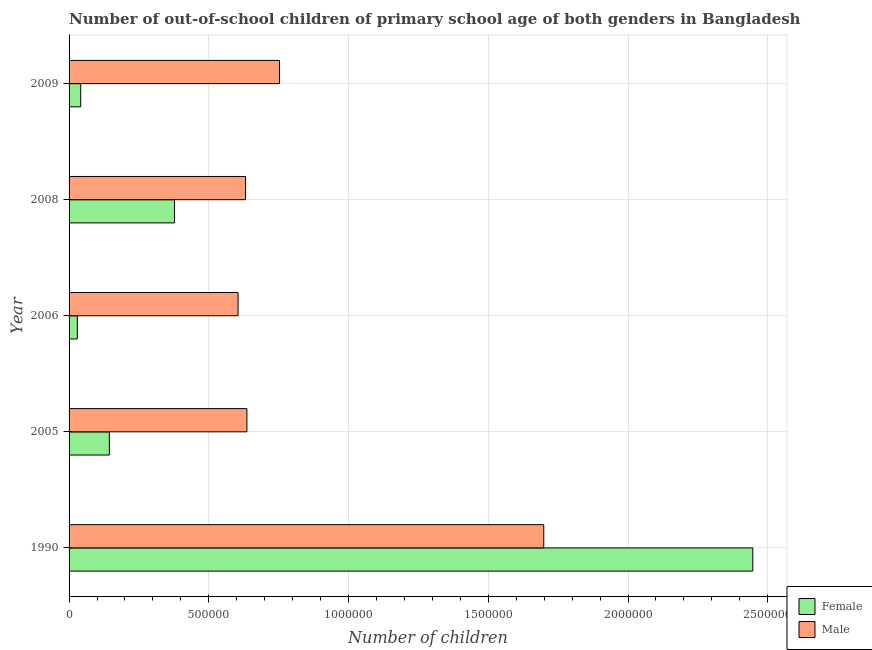How many different coloured bars are there?
Offer a very short reply. 2. Are the number of bars per tick equal to the number of legend labels?
Keep it short and to the point. Yes. How many bars are there on the 1st tick from the top?
Give a very brief answer. 2. In how many cases, is the number of bars for a given year not equal to the number of legend labels?
Provide a succinct answer. 0. What is the number of female out-of-school students in 2009?
Give a very brief answer. 4.16e+04. Across all years, what is the maximum number of female out-of-school students?
Offer a very short reply. 2.45e+06. Across all years, what is the minimum number of female out-of-school students?
Provide a succinct answer. 2.95e+04. In which year was the number of female out-of-school students maximum?
Offer a terse response. 1990. In which year was the number of male out-of-school students minimum?
Your answer should be very brief. 2006. What is the total number of female out-of-school students in the graph?
Offer a very short reply. 3.04e+06. What is the difference between the number of female out-of-school students in 2006 and that in 2008?
Make the answer very short. -3.48e+05. What is the difference between the number of male out-of-school students in 2005 and the number of female out-of-school students in 2008?
Your answer should be very brief. 2.59e+05. What is the average number of male out-of-school students per year?
Your answer should be very brief. 8.65e+05. In the year 2009, what is the difference between the number of female out-of-school students and number of male out-of-school students?
Ensure brevity in your answer.  -7.11e+05. In how many years, is the number of male out-of-school students greater than 900000 ?
Ensure brevity in your answer.  1. What is the ratio of the number of female out-of-school students in 1990 to that in 2009?
Provide a short and direct response. 58.8. Is the difference between the number of male out-of-school students in 1990 and 2008 greater than the difference between the number of female out-of-school students in 1990 and 2008?
Ensure brevity in your answer.  No. What is the difference between the highest and the second highest number of female out-of-school students?
Offer a terse response. 2.07e+06. What is the difference between the highest and the lowest number of male out-of-school students?
Give a very brief answer. 1.09e+06. In how many years, is the number of female out-of-school students greater than the average number of female out-of-school students taken over all years?
Provide a short and direct response. 1. Is the sum of the number of male out-of-school students in 1990 and 2006 greater than the maximum number of female out-of-school students across all years?
Ensure brevity in your answer.  No. Are all the bars in the graph horizontal?
Your answer should be very brief. Yes. How many years are there in the graph?
Ensure brevity in your answer.  5. What is the difference between two consecutive major ticks on the X-axis?
Offer a very short reply. 5.00e+05. Where does the legend appear in the graph?
Your answer should be compact. Bottom right. How many legend labels are there?
Ensure brevity in your answer.  2. How are the legend labels stacked?
Provide a short and direct response. Vertical. What is the title of the graph?
Your answer should be very brief. Number of out-of-school children of primary school age of both genders in Bangladesh. Does "Public funds" appear as one of the legend labels in the graph?
Your answer should be very brief. No. What is the label or title of the X-axis?
Provide a short and direct response. Number of children. What is the Number of children in Female in 1990?
Provide a short and direct response. 2.45e+06. What is the Number of children in Male in 1990?
Offer a very short reply. 1.70e+06. What is the Number of children in Female in 2005?
Make the answer very short. 1.44e+05. What is the Number of children in Male in 2005?
Your response must be concise. 6.36e+05. What is the Number of children of Female in 2006?
Make the answer very short. 2.95e+04. What is the Number of children of Male in 2006?
Your response must be concise. 6.05e+05. What is the Number of children in Female in 2008?
Ensure brevity in your answer.  3.77e+05. What is the Number of children of Male in 2008?
Make the answer very short. 6.31e+05. What is the Number of children in Female in 2009?
Your answer should be very brief. 4.16e+04. What is the Number of children in Male in 2009?
Provide a short and direct response. 7.53e+05. Across all years, what is the maximum Number of children of Female?
Ensure brevity in your answer.  2.45e+06. Across all years, what is the maximum Number of children in Male?
Make the answer very short. 1.70e+06. Across all years, what is the minimum Number of children of Female?
Offer a terse response. 2.95e+04. Across all years, what is the minimum Number of children of Male?
Offer a very short reply. 6.05e+05. What is the total Number of children of Female in the graph?
Offer a very short reply. 3.04e+06. What is the total Number of children in Male in the graph?
Offer a terse response. 4.32e+06. What is the difference between the Number of children in Female in 1990 and that in 2005?
Offer a terse response. 2.30e+06. What is the difference between the Number of children in Male in 1990 and that in 2005?
Your response must be concise. 1.06e+06. What is the difference between the Number of children in Female in 1990 and that in 2006?
Your response must be concise. 2.42e+06. What is the difference between the Number of children in Male in 1990 and that in 2006?
Your answer should be very brief. 1.09e+06. What is the difference between the Number of children of Female in 1990 and that in 2008?
Your answer should be compact. 2.07e+06. What is the difference between the Number of children of Male in 1990 and that in 2008?
Offer a very short reply. 1.07e+06. What is the difference between the Number of children of Female in 1990 and that in 2009?
Give a very brief answer. 2.40e+06. What is the difference between the Number of children of Male in 1990 and that in 2009?
Offer a very short reply. 9.46e+05. What is the difference between the Number of children of Female in 2005 and that in 2006?
Your answer should be compact. 1.15e+05. What is the difference between the Number of children of Male in 2005 and that in 2006?
Make the answer very short. 3.17e+04. What is the difference between the Number of children in Female in 2005 and that in 2008?
Keep it short and to the point. -2.33e+05. What is the difference between the Number of children of Male in 2005 and that in 2008?
Provide a succinct answer. 4960. What is the difference between the Number of children in Female in 2005 and that in 2009?
Your response must be concise. 1.02e+05. What is the difference between the Number of children in Male in 2005 and that in 2009?
Ensure brevity in your answer.  -1.16e+05. What is the difference between the Number of children in Female in 2006 and that in 2008?
Your answer should be compact. -3.48e+05. What is the difference between the Number of children of Male in 2006 and that in 2008?
Your answer should be compact. -2.67e+04. What is the difference between the Number of children of Female in 2006 and that in 2009?
Offer a very short reply. -1.21e+04. What is the difference between the Number of children in Male in 2006 and that in 2009?
Give a very brief answer. -1.48e+05. What is the difference between the Number of children in Female in 2008 and that in 2009?
Provide a succinct answer. 3.36e+05. What is the difference between the Number of children of Male in 2008 and that in 2009?
Give a very brief answer. -1.21e+05. What is the difference between the Number of children in Female in 1990 and the Number of children in Male in 2005?
Provide a succinct answer. 1.81e+06. What is the difference between the Number of children of Female in 1990 and the Number of children of Male in 2006?
Provide a short and direct response. 1.84e+06. What is the difference between the Number of children of Female in 1990 and the Number of children of Male in 2008?
Provide a succinct answer. 1.82e+06. What is the difference between the Number of children of Female in 1990 and the Number of children of Male in 2009?
Give a very brief answer. 1.69e+06. What is the difference between the Number of children in Female in 2005 and the Number of children in Male in 2006?
Ensure brevity in your answer.  -4.61e+05. What is the difference between the Number of children of Female in 2005 and the Number of children of Male in 2008?
Make the answer very short. -4.87e+05. What is the difference between the Number of children in Female in 2005 and the Number of children in Male in 2009?
Keep it short and to the point. -6.09e+05. What is the difference between the Number of children in Female in 2006 and the Number of children in Male in 2008?
Give a very brief answer. -6.02e+05. What is the difference between the Number of children of Female in 2006 and the Number of children of Male in 2009?
Keep it short and to the point. -7.23e+05. What is the difference between the Number of children in Female in 2008 and the Number of children in Male in 2009?
Keep it short and to the point. -3.76e+05. What is the average Number of children in Female per year?
Your response must be concise. 6.08e+05. What is the average Number of children in Male per year?
Your answer should be very brief. 8.65e+05. In the year 1990, what is the difference between the Number of children in Female and Number of children in Male?
Provide a succinct answer. 7.48e+05. In the year 2005, what is the difference between the Number of children in Female and Number of children in Male?
Make the answer very short. -4.92e+05. In the year 2006, what is the difference between the Number of children of Female and Number of children of Male?
Your answer should be compact. -5.75e+05. In the year 2008, what is the difference between the Number of children in Female and Number of children in Male?
Offer a very short reply. -2.54e+05. In the year 2009, what is the difference between the Number of children in Female and Number of children in Male?
Your response must be concise. -7.11e+05. What is the ratio of the Number of children of Female in 1990 to that in 2005?
Your response must be concise. 16.98. What is the ratio of the Number of children in Male in 1990 to that in 2005?
Ensure brevity in your answer.  2.67. What is the ratio of the Number of children in Female in 1990 to that in 2006?
Offer a very short reply. 82.8. What is the ratio of the Number of children in Male in 1990 to that in 2006?
Make the answer very short. 2.81. What is the ratio of the Number of children in Female in 1990 to that in 2008?
Ensure brevity in your answer.  6.49. What is the ratio of the Number of children in Male in 1990 to that in 2008?
Offer a terse response. 2.69. What is the ratio of the Number of children in Female in 1990 to that in 2009?
Keep it short and to the point. 58.8. What is the ratio of the Number of children in Male in 1990 to that in 2009?
Offer a terse response. 2.26. What is the ratio of the Number of children in Female in 2005 to that in 2006?
Offer a very short reply. 4.88. What is the ratio of the Number of children in Male in 2005 to that in 2006?
Provide a succinct answer. 1.05. What is the ratio of the Number of children of Female in 2005 to that in 2008?
Give a very brief answer. 0.38. What is the ratio of the Number of children in Male in 2005 to that in 2008?
Your response must be concise. 1.01. What is the ratio of the Number of children in Female in 2005 to that in 2009?
Your answer should be very brief. 3.46. What is the ratio of the Number of children in Male in 2005 to that in 2009?
Make the answer very short. 0.85. What is the ratio of the Number of children of Female in 2006 to that in 2008?
Offer a very short reply. 0.08. What is the ratio of the Number of children of Male in 2006 to that in 2008?
Offer a very short reply. 0.96. What is the ratio of the Number of children of Female in 2006 to that in 2009?
Your response must be concise. 0.71. What is the ratio of the Number of children in Male in 2006 to that in 2009?
Your answer should be very brief. 0.8. What is the ratio of the Number of children of Female in 2008 to that in 2009?
Offer a terse response. 9.07. What is the ratio of the Number of children of Male in 2008 to that in 2009?
Offer a terse response. 0.84. What is the difference between the highest and the second highest Number of children of Female?
Keep it short and to the point. 2.07e+06. What is the difference between the highest and the second highest Number of children of Male?
Keep it short and to the point. 9.46e+05. What is the difference between the highest and the lowest Number of children in Female?
Give a very brief answer. 2.42e+06. What is the difference between the highest and the lowest Number of children of Male?
Your answer should be very brief. 1.09e+06. 